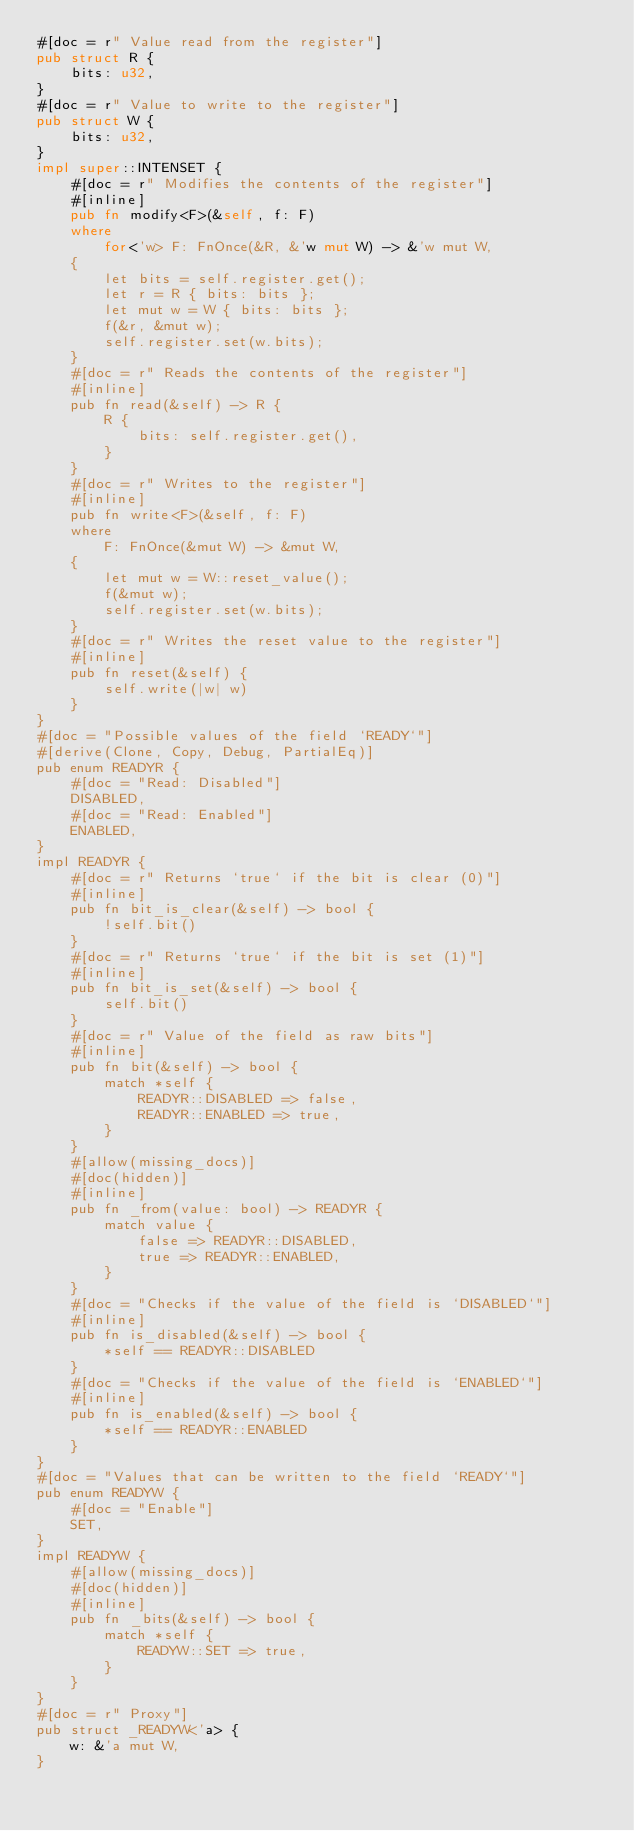Convert code to text. <code><loc_0><loc_0><loc_500><loc_500><_Rust_>#[doc = r" Value read from the register"]
pub struct R {
    bits: u32,
}
#[doc = r" Value to write to the register"]
pub struct W {
    bits: u32,
}
impl super::INTENSET {
    #[doc = r" Modifies the contents of the register"]
    #[inline]
    pub fn modify<F>(&self, f: F)
    where
        for<'w> F: FnOnce(&R, &'w mut W) -> &'w mut W,
    {
        let bits = self.register.get();
        let r = R { bits: bits };
        let mut w = W { bits: bits };
        f(&r, &mut w);
        self.register.set(w.bits);
    }
    #[doc = r" Reads the contents of the register"]
    #[inline]
    pub fn read(&self) -> R {
        R {
            bits: self.register.get(),
        }
    }
    #[doc = r" Writes to the register"]
    #[inline]
    pub fn write<F>(&self, f: F)
    where
        F: FnOnce(&mut W) -> &mut W,
    {
        let mut w = W::reset_value();
        f(&mut w);
        self.register.set(w.bits);
    }
    #[doc = r" Writes the reset value to the register"]
    #[inline]
    pub fn reset(&self) {
        self.write(|w| w)
    }
}
#[doc = "Possible values of the field `READY`"]
#[derive(Clone, Copy, Debug, PartialEq)]
pub enum READYR {
    #[doc = "Read: Disabled"]
    DISABLED,
    #[doc = "Read: Enabled"]
    ENABLED,
}
impl READYR {
    #[doc = r" Returns `true` if the bit is clear (0)"]
    #[inline]
    pub fn bit_is_clear(&self) -> bool {
        !self.bit()
    }
    #[doc = r" Returns `true` if the bit is set (1)"]
    #[inline]
    pub fn bit_is_set(&self) -> bool {
        self.bit()
    }
    #[doc = r" Value of the field as raw bits"]
    #[inline]
    pub fn bit(&self) -> bool {
        match *self {
            READYR::DISABLED => false,
            READYR::ENABLED => true,
        }
    }
    #[allow(missing_docs)]
    #[doc(hidden)]
    #[inline]
    pub fn _from(value: bool) -> READYR {
        match value {
            false => READYR::DISABLED,
            true => READYR::ENABLED,
        }
    }
    #[doc = "Checks if the value of the field is `DISABLED`"]
    #[inline]
    pub fn is_disabled(&self) -> bool {
        *self == READYR::DISABLED
    }
    #[doc = "Checks if the value of the field is `ENABLED`"]
    #[inline]
    pub fn is_enabled(&self) -> bool {
        *self == READYR::ENABLED
    }
}
#[doc = "Values that can be written to the field `READY`"]
pub enum READYW {
    #[doc = "Enable"]
    SET,
}
impl READYW {
    #[allow(missing_docs)]
    #[doc(hidden)]
    #[inline]
    pub fn _bits(&self) -> bool {
        match *self {
            READYW::SET => true,
        }
    }
}
#[doc = r" Proxy"]
pub struct _READYW<'a> {
    w: &'a mut W,
}</code> 